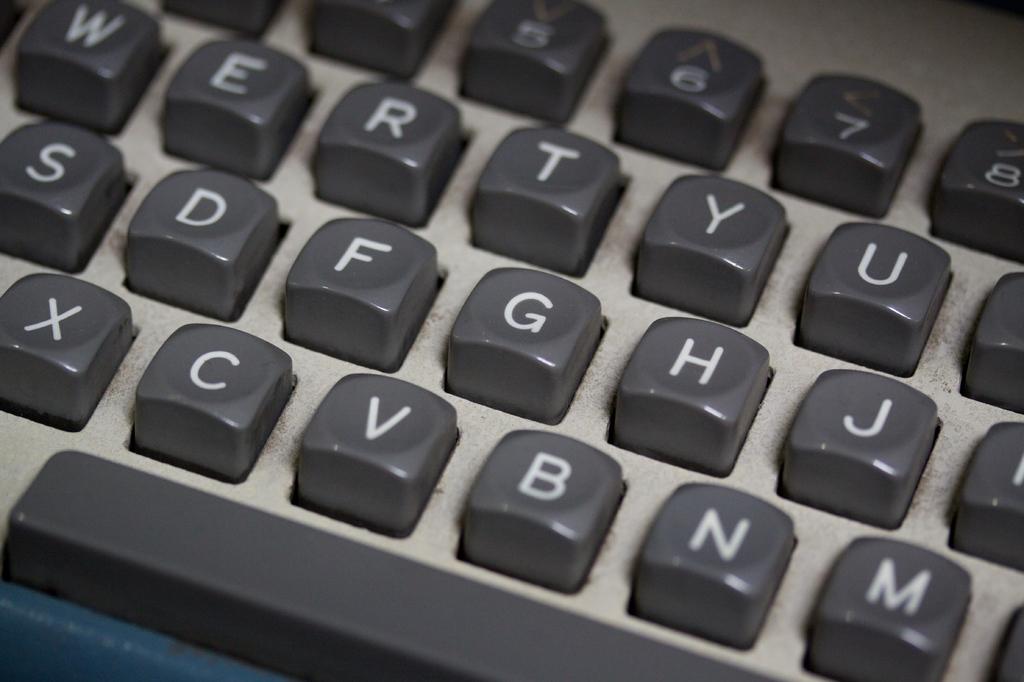What key is left of g?
Your answer should be compact. F. What key comes after x?
Offer a terse response. C. 